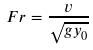<formula> <loc_0><loc_0><loc_500><loc_500>F r = \frac { v } { \sqrt { g y _ { 0 } } }</formula> 